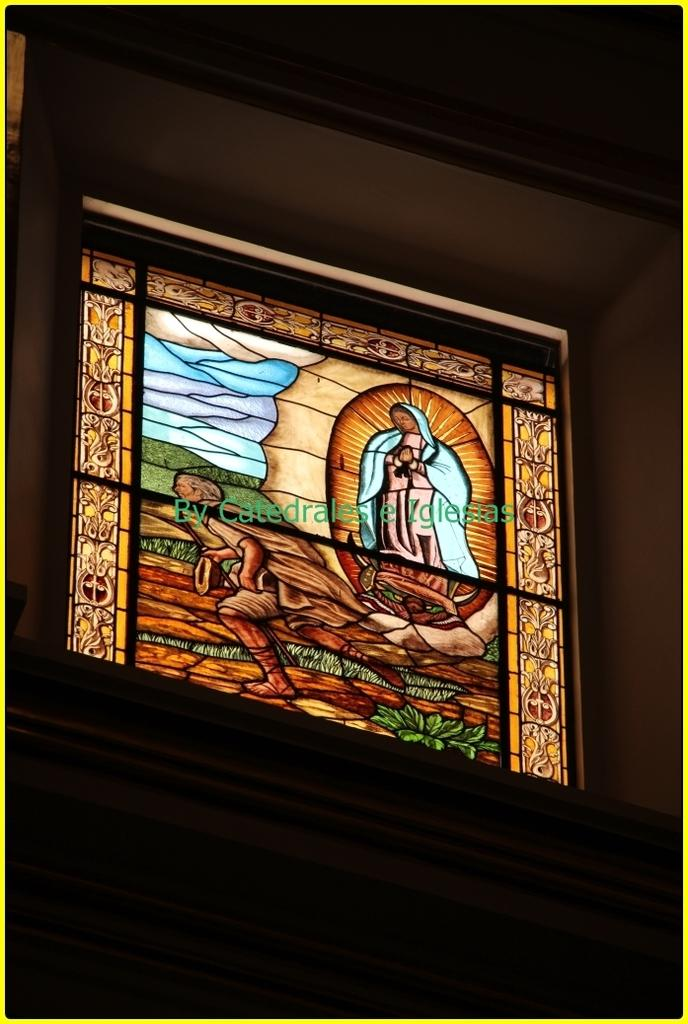What type of structure can be seen in the image? There is a glass window in the image. What is depicted on the glass window? The painting of a human is present in the image. What type of natural scenery is visible in the image? There are trees in the image. What type of cactus is present in the image? There is no cactus present in the image; it features a glass window with a painting of a human and trees in the background. 